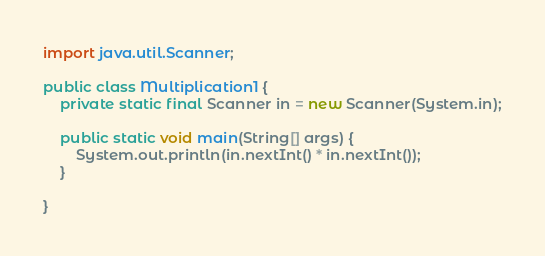Convert code to text. <code><loc_0><loc_0><loc_500><loc_500><_Java_>import java.util.Scanner;

public class Multiplication1 {
    private static final Scanner in = new Scanner(System.in);

    public static void main(String[] args) {
        System.out.println(in.nextInt() * in.nextInt());
    }

}
</code> 